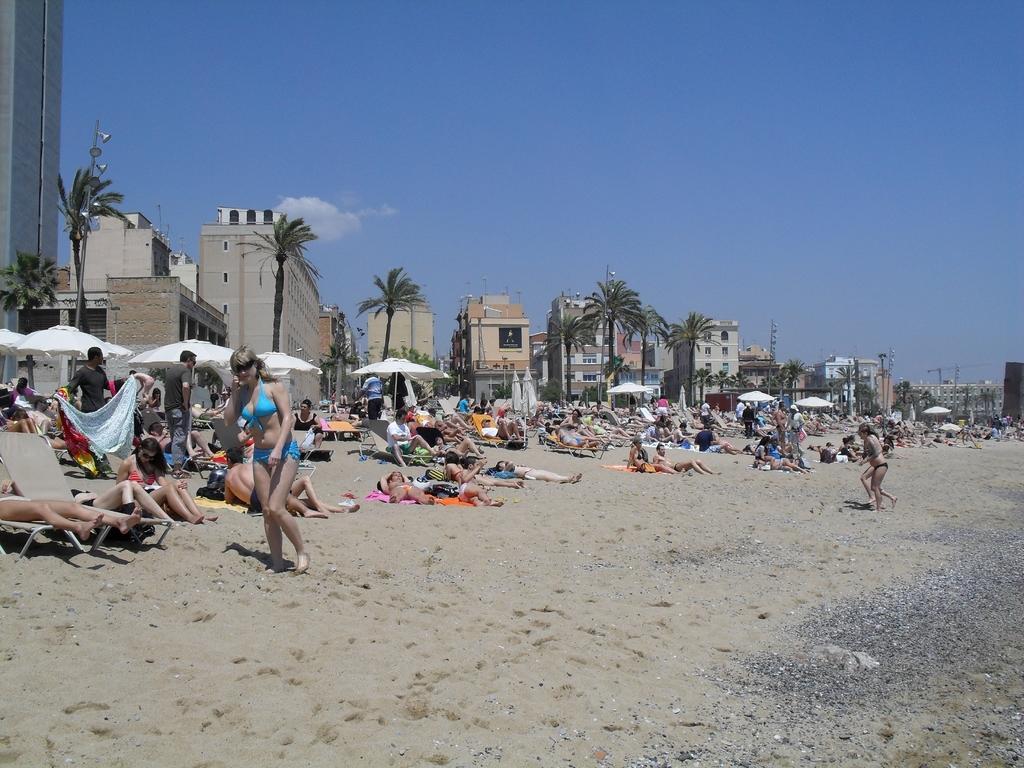Describe this image in one or two sentences. In this picture we can see some people are standing, some people are walking and some people are lying, there are some stones at the right bottom, we can see umbrellas in the middle, in the background there are trees and buildings, we can see the sky at the top of the picture. 